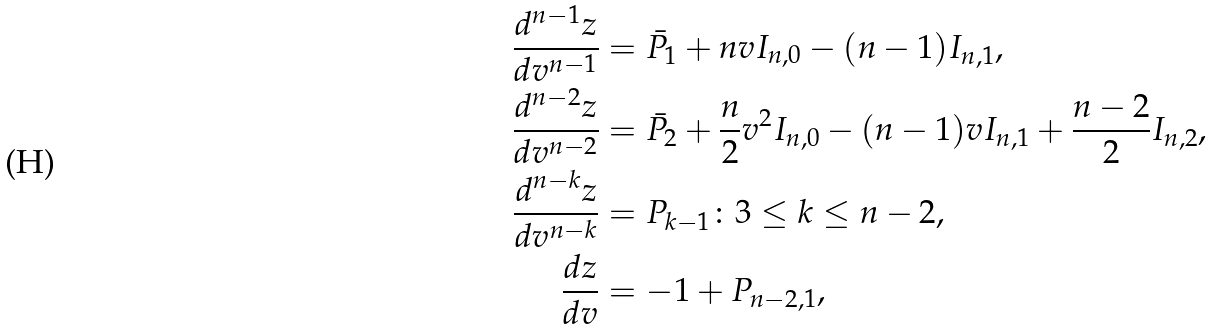Convert formula to latex. <formula><loc_0><loc_0><loc_500><loc_500>\frac { d ^ { n - 1 } z } { d v ^ { n - 1 } } & = \bar { P } _ { 1 } + n v I _ { n , 0 } - ( n - 1 ) I _ { n , 1 } , \\ \frac { d ^ { n - 2 } z } { d v ^ { n - 2 } } & = \bar { P } _ { 2 } + \frac { n } { 2 } v ^ { 2 } I _ { n , 0 } - ( n - 1 ) v I _ { n , 1 } + \frac { n - 2 } { 2 } I _ { n , 2 } , \\ \frac { d ^ { n - k } z } { d v ^ { n - k } } & = P _ { k - 1 } \colon 3 \leq k \leq n - 2 , \\ \frac { d z } { d v } & = - 1 + P _ { n - 2 , 1 } ,</formula> 